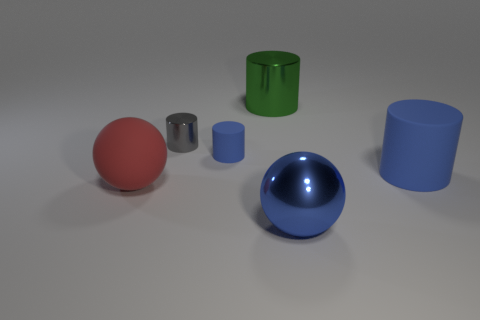Is there a big metallic thing that has the same color as the big matte cylinder?
Your answer should be compact. Yes. What number of big blue cylinders have the same material as the large red sphere?
Give a very brief answer. 1. How many metal cylinders are on the right side of the small rubber cylinder?
Offer a terse response. 1. Is the big sphere to the left of the small blue rubber cylinder made of the same material as the large blue object that is in front of the large blue rubber thing?
Offer a terse response. No. Are there more blue cylinders to the left of the green cylinder than tiny blue objects that are on the right side of the large matte cylinder?
Your answer should be compact. Yes. There is a sphere that is the same color as the tiny matte cylinder; what material is it?
Make the answer very short. Metal. There is a large thing that is in front of the gray object and behind the matte ball; what is its material?
Give a very brief answer. Rubber. Are the big blue ball and the big cylinder that is to the left of the big blue shiny thing made of the same material?
Your response must be concise. Yes. What number of objects are either large matte cylinders or blue things to the right of the metal sphere?
Provide a short and direct response. 1. There is a ball on the right side of the big red sphere; is its size the same as the thing behind the tiny shiny thing?
Keep it short and to the point. Yes. 